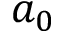<formula> <loc_0><loc_0><loc_500><loc_500>a _ { 0 }</formula> 